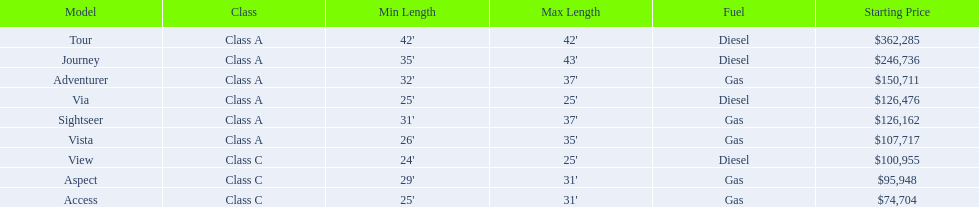What are the prices? $362,285, $246,736, $150,711, $126,476, $126,162, $107,717, $100,955, $95,948, $74,704. What is the top price? $362,285. What model has this price? Tour. 